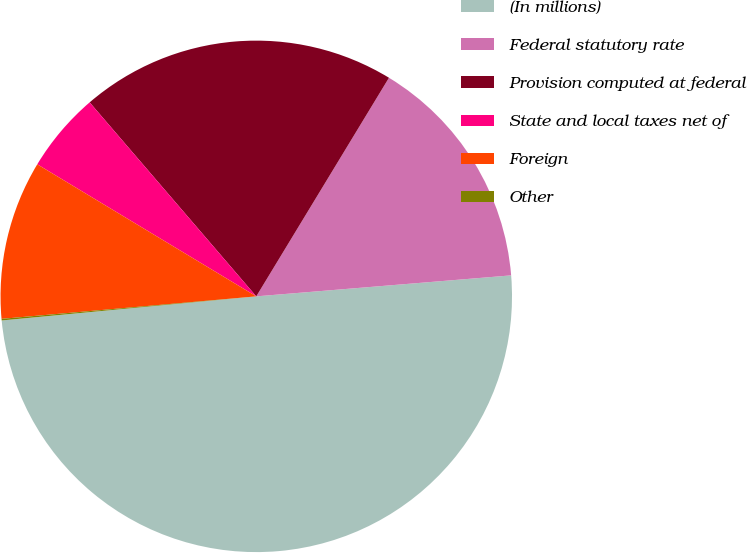<chart> <loc_0><loc_0><loc_500><loc_500><pie_chart><fcel>(In millions)<fcel>Federal statutory rate<fcel>Provision computed at federal<fcel>State and local taxes net of<fcel>Foreign<fcel>Other<nl><fcel>49.81%<fcel>15.01%<fcel>19.98%<fcel>5.07%<fcel>10.04%<fcel>0.1%<nl></chart> 